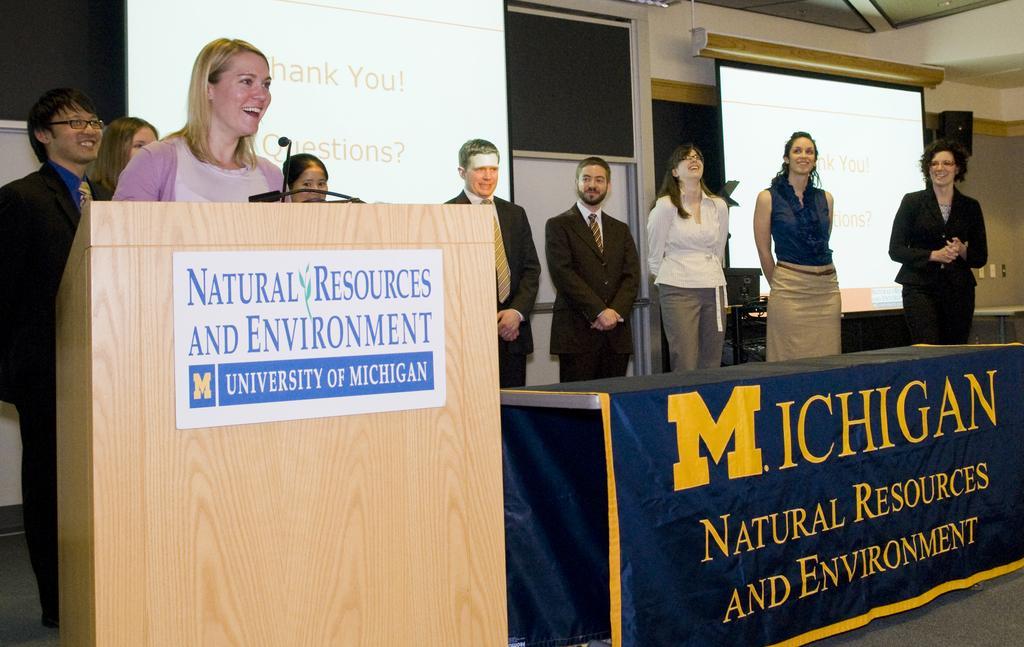How would you summarize this image in a sentence or two? In this image we can see a woman standing and smiling in front of the podium. We can also see the text paper and also the mike. In the background, we can see the people standing and smiling. We can also see the screens, board, wall and also the sound box. On the right there is a table and also the text present on the cloth. We can also see the floor. 